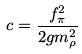<formula> <loc_0><loc_0><loc_500><loc_500>c = \frac { f ^ { 2 } _ { \pi } } { 2 g m ^ { 2 } _ { \rho } }</formula> 